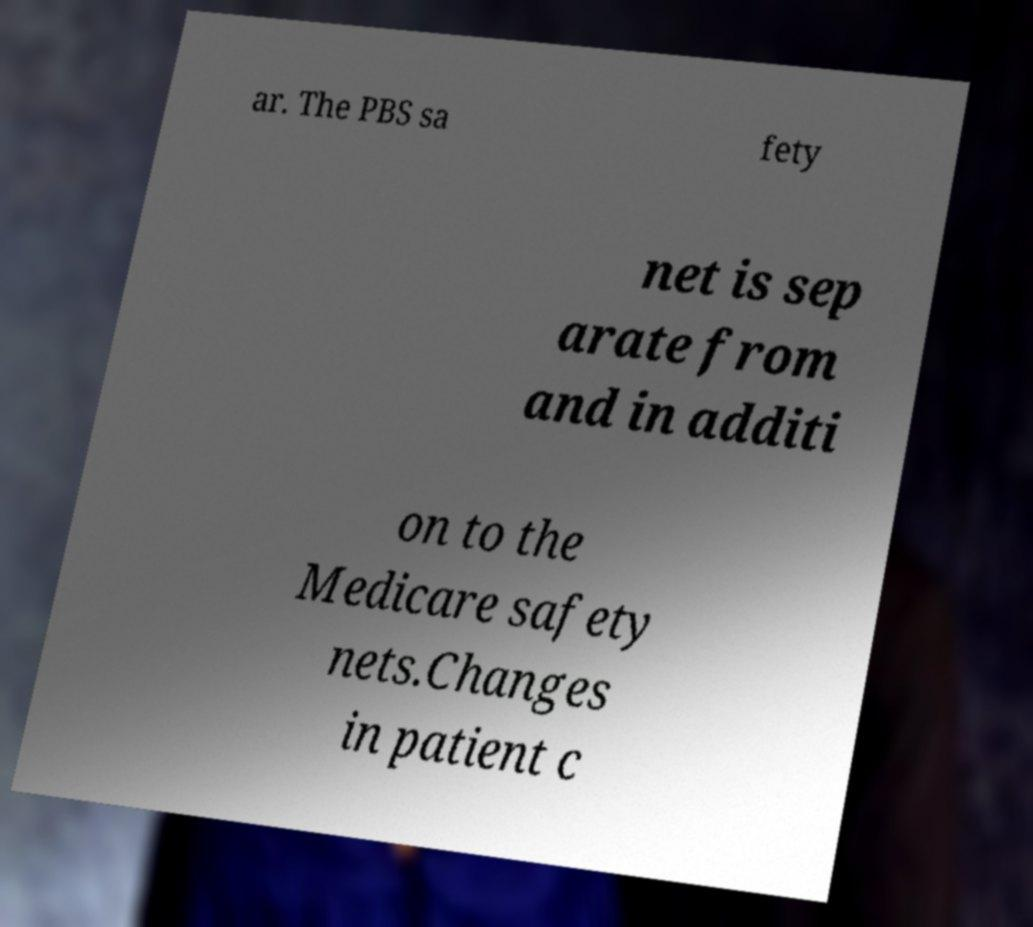Could you extract and type out the text from this image? ar. The PBS sa fety net is sep arate from and in additi on to the Medicare safety nets.Changes in patient c 